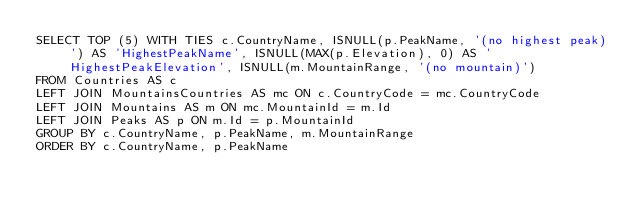<code> <loc_0><loc_0><loc_500><loc_500><_SQL_>SELECT TOP (5) WITH TIES c.CountryName, ISNULL(p.PeakName, '(no highest peak)') AS 'HighestPeakName', ISNULL(MAX(p.Elevation), 0) AS 'HighestPeakElevation', ISNULL(m.MountainRange, '(no mountain)')
FROM Countries AS c
LEFT JOIN MountainsCountries AS mc ON c.CountryCode = mc.CountryCode
LEFT JOIN Mountains AS m ON mc.MountainId = m.Id
LEFT JOIN Peaks AS p ON m.Id = p.MountainId
GROUP BY c.CountryName, p.PeakName, m.MountainRange
ORDER BY c.CountryName, p.PeakName
</code> 